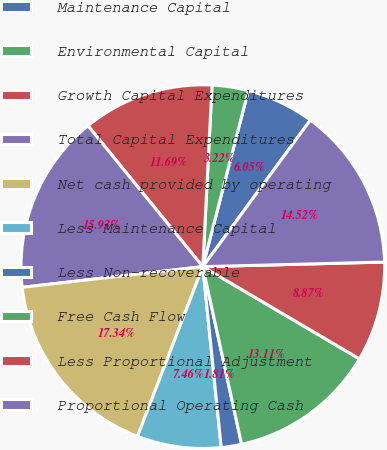<chart> <loc_0><loc_0><loc_500><loc_500><pie_chart><fcel>Maintenance Capital<fcel>Environmental Capital<fcel>Growth Capital Expenditures<fcel>Total Capital Expenditures<fcel>Net cash provided by operating<fcel>Less Maintenance Capital<fcel>Less Non-recoverable<fcel>Free Cash Flow<fcel>Less Proportional Adjustment<fcel>Proportional Operating Cash<nl><fcel>6.05%<fcel>3.22%<fcel>11.69%<fcel>15.93%<fcel>17.34%<fcel>7.46%<fcel>1.81%<fcel>13.11%<fcel>8.87%<fcel>14.52%<nl></chart> 